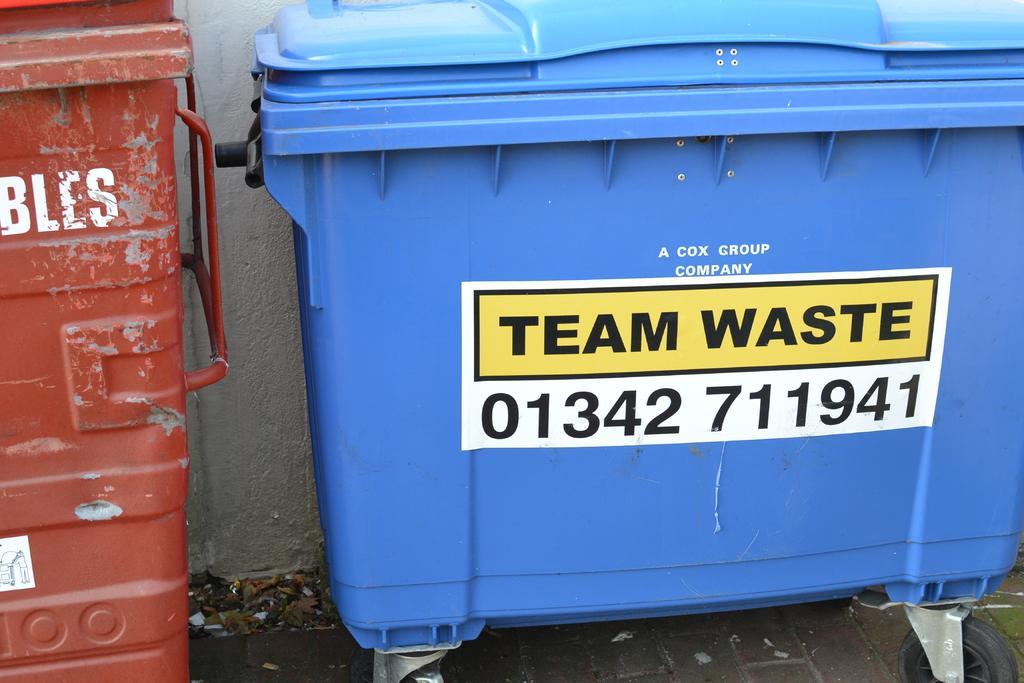Please provide a concise description of this image. In this picture we can see bins and there is a poster. In the background we can see a wall. 